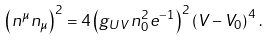Convert formula to latex. <formula><loc_0><loc_0><loc_500><loc_500>\left ( n ^ { \mu } n _ { \mu } \right ) ^ { 2 } = 4 \left ( g _ { U V } \, n _ { 0 } ^ { 2 } e ^ { - 1 } \right ) ^ { 2 } \left ( V - V _ { 0 } \right ) ^ { 4 } \, .</formula> 